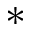<formula> <loc_0><loc_0><loc_500><loc_500>\ast</formula> 